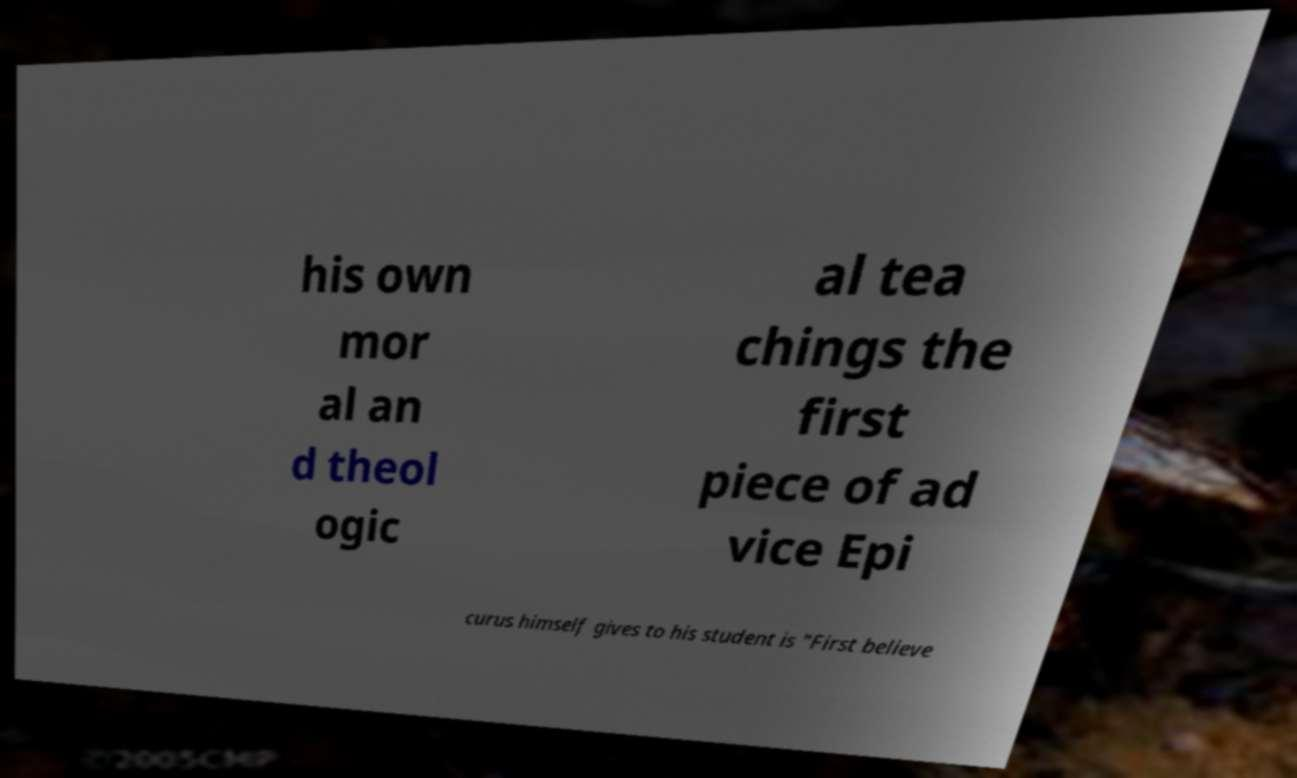Can you read and provide the text displayed in the image?This photo seems to have some interesting text. Can you extract and type it out for me? his own mor al an d theol ogic al tea chings the first piece of ad vice Epi curus himself gives to his student is "First believe 